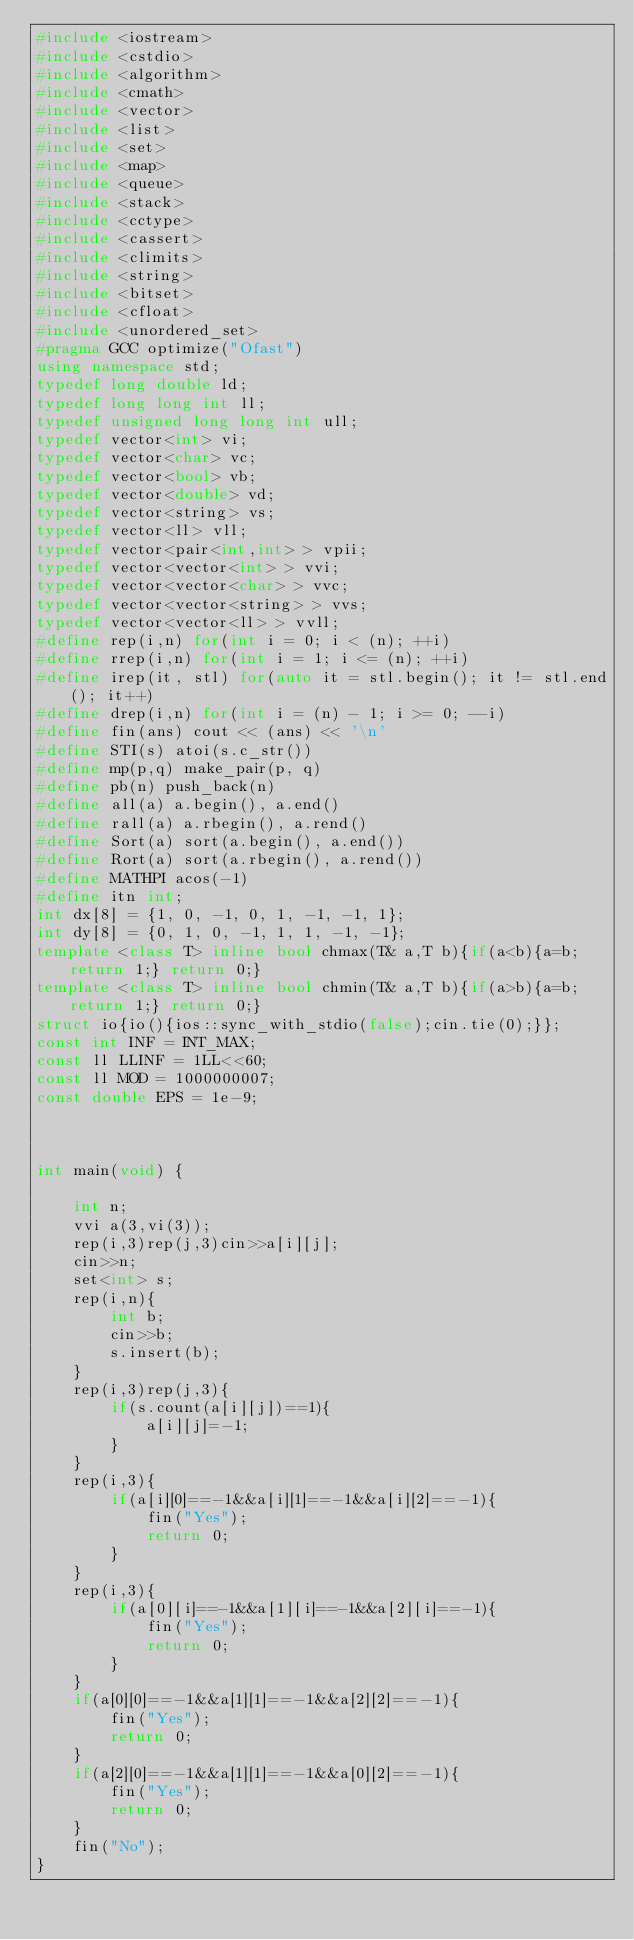<code> <loc_0><loc_0><loc_500><loc_500><_C++_>#include <iostream>
#include <cstdio>
#include <algorithm>
#include <cmath>
#include <vector>
#include <list>
#include <set>
#include <map>
#include <queue>
#include <stack>
#include <cctype>
#include <cassert>
#include <climits>
#include <string>
#include <bitset>
#include <cfloat>
#include <unordered_set>
#pragma GCC optimize("Ofast")
using namespace std;
typedef long double ld;
typedef long long int ll;
typedef unsigned long long int ull;
typedef vector<int> vi;
typedef vector<char> vc;
typedef vector<bool> vb;
typedef vector<double> vd;
typedef vector<string> vs;
typedef vector<ll> vll;
typedef vector<pair<int,int> > vpii;
typedef vector<vector<int> > vvi;
typedef vector<vector<char> > vvc;
typedef vector<vector<string> > vvs;
typedef vector<vector<ll> > vvll;
#define rep(i,n) for(int i = 0; i < (n); ++i)
#define rrep(i,n) for(int i = 1; i <= (n); ++i)
#define irep(it, stl) for(auto it = stl.begin(); it != stl.end(); it++)
#define drep(i,n) for(int i = (n) - 1; i >= 0; --i)
#define fin(ans) cout << (ans) << '\n'
#define STI(s) atoi(s.c_str())
#define mp(p,q) make_pair(p, q)
#define pb(n) push_back(n)
#define all(a) a.begin(), a.end()
#define rall(a) a.rbegin(), a.rend()
#define Sort(a) sort(a.begin(), a.end())
#define Rort(a) sort(a.rbegin(), a.rend())
#define MATHPI acos(-1)
#define itn int;
int dx[8] = {1, 0, -1, 0, 1, -1, -1, 1};
int dy[8] = {0, 1, 0, -1, 1, 1, -1, -1};
template <class T> inline bool chmax(T& a,T b){if(a<b){a=b;return 1;} return 0;}
template <class T> inline bool chmin(T& a,T b){if(a>b){a=b;return 1;} return 0;}
struct io{io(){ios::sync_with_stdio(false);cin.tie(0);}};
const int INF = INT_MAX;
const ll LLINF = 1LL<<60;
const ll MOD = 1000000007;
const double EPS = 1e-9;



int main(void) {

    int n;
    vvi a(3,vi(3));
    rep(i,3)rep(j,3)cin>>a[i][j];
    cin>>n;
    set<int> s;
    rep(i,n){
        int b;
        cin>>b;
        s.insert(b);
    }
    rep(i,3)rep(j,3){
        if(s.count(a[i][j])==1){
            a[i][j]=-1;
        }
    }
    rep(i,3){
        if(a[i][0]==-1&&a[i][1]==-1&&a[i][2]==-1){
            fin("Yes");
            return 0;
        }
    }
    rep(i,3){
        if(a[0][i]==-1&&a[1][i]==-1&&a[2][i]==-1){
            fin("Yes");
            return 0;
        }
    }
    if(a[0][0]==-1&&a[1][1]==-1&&a[2][2]==-1){
        fin("Yes");
        return 0;
    }
    if(a[2][0]==-1&&a[1][1]==-1&&a[0][2]==-1){
        fin("Yes");
        return 0;
    }
    fin("No");
}</code> 